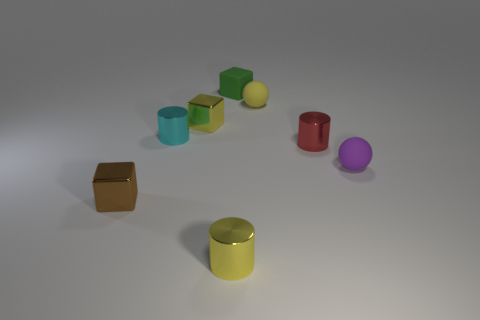Subtract all metal cubes. How many cubes are left? 1 Add 2 brown blocks. How many objects exist? 10 Subtract 1 cylinders. How many cylinders are left? 2 Subtract all spheres. How many objects are left? 6 Subtract all tiny blue rubber cylinders. Subtract all brown objects. How many objects are left? 7 Add 8 yellow balls. How many yellow balls are left? 9 Add 6 green things. How many green things exist? 7 Subtract all yellow cubes. How many cubes are left? 2 Subtract 0 purple cylinders. How many objects are left? 8 Subtract all cyan spheres. Subtract all brown cylinders. How many spheres are left? 2 